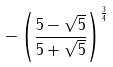Convert formula to latex. <formula><loc_0><loc_0><loc_500><loc_500>- \left ( \frac { 5 - \sqrt { 5 } } { 5 + \sqrt { 5 } } \right ) ^ { \frac { 3 } { 4 } }</formula> 